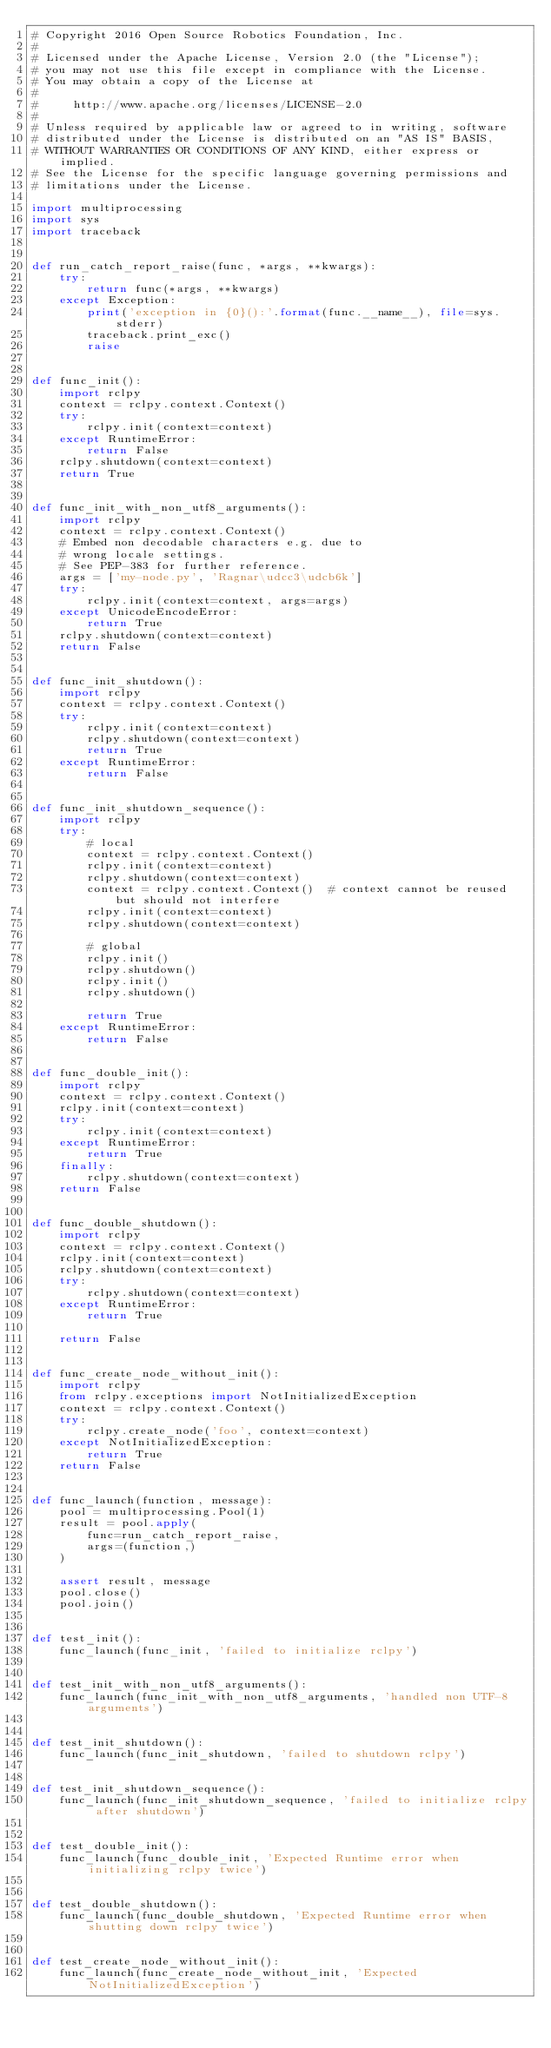<code> <loc_0><loc_0><loc_500><loc_500><_Python_># Copyright 2016 Open Source Robotics Foundation, Inc.
#
# Licensed under the Apache License, Version 2.0 (the "License");
# you may not use this file except in compliance with the License.
# You may obtain a copy of the License at
#
#     http://www.apache.org/licenses/LICENSE-2.0
#
# Unless required by applicable law or agreed to in writing, software
# distributed under the License is distributed on an "AS IS" BASIS,
# WITHOUT WARRANTIES OR CONDITIONS OF ANY KIND, either express or implied.
# See the License for the specific language governing permissions and
# limitations under the License.

import multiprocessing
import sys
import traceback


def run_catch_report_raise(func, *args, **kwargs):
    try:
        return func(*args, **kwargs)
    except Exception:
        print('exception in {0}():'.format(func.__name__), file=sys.stderr)
        traceback.print_exc()
        raise


def func_init():
    import rclpy
    context = rclpy.context.Context()
    try:
        rclpy.init(context=context)
    except RuntimeError:
        return False
    rclpy.shutdown(context=context)
    return True


def func_init_with_non_utf8_arguments():
    import rclpy
    context = rclpy.context.Context()
    # Embed non decodable characters e.g. due to
    # wrong locale settings.
    # See PEP-383 for further reference.
    args = ['my-node.py', 'Ragnar\udcc3\udcb6k']
    try:
        rclpy.init(context=context, args=args)
    except UnicodeEncodeError:
        return True
    rclpy.shutdown(context=context)
    return False


def func_init_shutdown():
    import rclpy
    context = rclpy.context.Context()
    try:
        rclpy.init(context=context)
        rclpy.shutdown(context=context)
        return True
    except RuntimeError:
        return False


def func_init_shutdown_sequence():
    import rclpy
    try:
        # local
        context = rclpy.context.Context()
        rclpy.init(context=context)
        rclpy.shutdown(context=context)
        context = rclpy.context.Context()  # context cannot be reused but should not interfere
        rclpy.init(context=context)
        rclpy.shutdown(context=context)

        # global
        rclpy.init()
        rclpy.shutdown()
        rclpy.init()
        rclpy.shutdown()

        return True
    except RuntimeError:
        return False


def func_double_init():
    import rclpy
    context = rclpy.context.Context()
    rclpy.init(context=context)
    try:
        rclpy.init(context=context)
    except RuntimeError:
        return True
    finally:
        rclpy.shutdown(context=context)
    return False


def func_double_shutdown():
    import rclpy
    context = rclpy.context.Context()
    rclpy.init(context=context)
    rclpy.shutdown(context=context)
    try:
        rclpy.shutdown(context=context)
    except RuntimeError:
        return True

    return False


def func_create_node_without_init():
    import rclpy
    from rclpy.exceptions import NotInitializedException
    context = rclpy.context.Context()
    try:
        rclpy.create_node('foo', context=context)
    except NotInitializedException:
        return True
    return False


def func_launch(function, message):
    pool = multiprocessing.Pool(1)
    result = pool.apply(
        func=run_catch_report_raise,
        args=(function,)
    )

    assert result, message
    pool.close()
    pool.join()


def test_init():
    func_launch(func_init, 'failed to initialize rclpy')


def test_init_with_non_utf8_arguments():
    func_launch(func_init_with_non_utf8_arguments, 'handled non UTF-8 arguments')


def test_init_shutdown():
    func_launch(func_init_shutdown, 'failed to shutdown rclpy')


def test_init_shutdown_sequence():
    func_launch(func_init_shutdown_sequence, 'failed to initialize rclpy after shutdown')


def test_double_init():
    func_launch(func_double_init, 'Expected Runtime error when initializing rclpy twice')


def test_double_shutdown():
    func_launch(func_double_shutdown, 'Expected Runtime error when shutting down rclpy twice')


def test_create_node_without_init():
    func_launch(func_create_node_without_init, 'Expected NotInitializedException')
</code> 